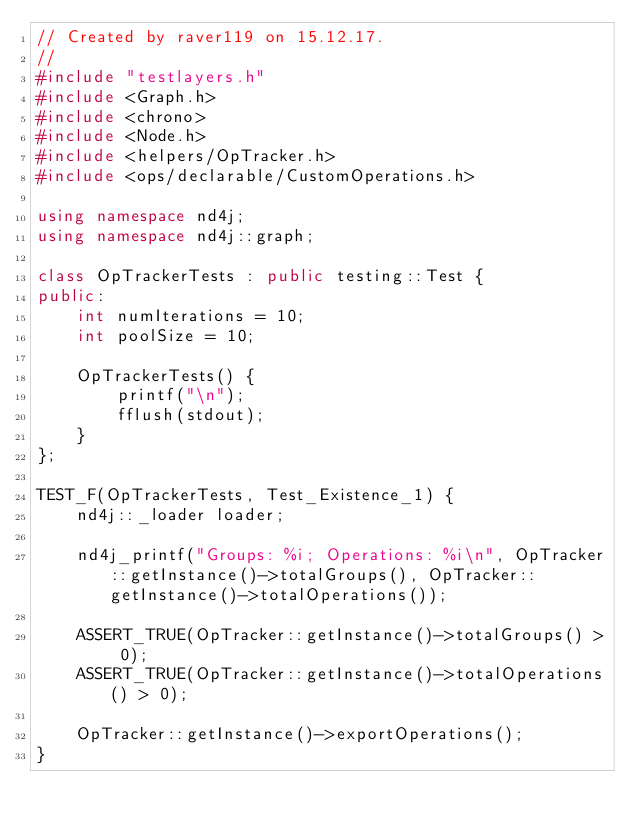Convert code to text. <code><loc_0><loc_0><loc_500><loc_500><_C++_>// Created by raver119 on 15.12.17.
//
#include "testlayers.h"
#include <Graph.h>
#include <chrono>
#include <Node.h>
#include <helpers/OpTracker.h>
#include <ops/declarable/CustomOperations.h>

using namespace nd4j;
using namespace nd4j::graph;

class OpTrackerTests : public testing::Test {
public:
    int numIterations = 10;
    int poolSize = 10;

    OpTrackerTests() {
        printf("\n");
        fflush(stdout);
    }
};

TEST_F(OpTrackerTests, Test_Existence_1) {
    nd4j::_loader loader;

    nd4j_printf("Groups: %i; Operations: %i\n", OpTracker::getInstance()->totalGroups(), OpTracker::getInstance()->totalOperations());

    ASSERT_TRUE(OpTracker::getInstance()->totalGroups() > 0);
    ASSERT_TRUE(OpTracker::getInstance()->totalOperations() > 0);

    OpTracker::getInstance()->exportOperations();
}




</code> 